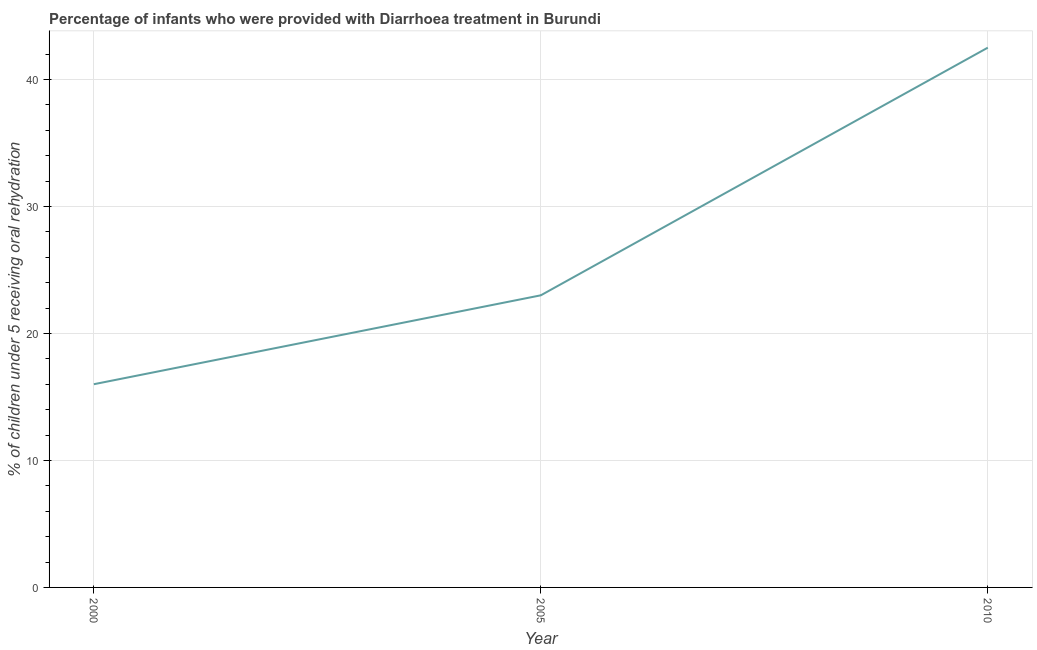What is the percentage of children who were provided with treatment diarrhoea in 2010?
Your answer should be compact. 42.5. Across all years, what is the maximum percentage of children who were provided with treatment diarrhoea?
Keep it short and to the point. 42.5. Across all years, what is the minimum percentage of children who were provided with treatment diarrhoea?
Offer a terse response. 16. In which year was the percentage of children who were provided with treatment diarrhoea maximum?
Provide a short and direct response. 2010. What is the sum of the percentage of children who were provided with treatment diarrhoea?
Your answer should be very brief. 81.5. What is the difference between the percentage of children who were provided with treatment diarrhoea in 2000 and 2005?
Provide a succinct answer. -7. What is the average percentage of children who were provided with treatment diarrhoea per year?
Your response must be concise. 27.17. In how many years, is the percentage of children who were provided with treatment diarrhoea greater than 16 %?
Keep it short and to the point. 2. What is the ratio of the percentage of children who were provided with treatment diarrhoea in 2000 to that in 2005?
Your answer should be compact. 0.7. Is the percentage of children who were provided with treatment diarrhoea in 2005 less than that in 2010?
Your answer should be compact. Yes. Is the sum of the percentage of children who were provided with treatment diarrhoea in 2000 and 2005 greater than the maximum percentage of children who were provided with treatment diarrhoea across all years?
Provide a short and direct response. No. In how many years, is the percentage of children who were provided with treatment diarrhoea greater than the average percentage of children who were provided with treatment diarrhoea taken over all years?
Provide a succinct answer. 1. How many years are there in the graph?
Provide a succinct answer. 3. What is the difference between two consecutive major ticks on the Y-axis?
Your response must be concise. 10. What is the title of the graph?
Make the answer very short. Percentage of infants who were provided with Diarrhoea treatment in Burundi. What is the label or title of the X-axis?
Your response must be concise. Year. What is the label or title of the Y-axis?
Provide a succinct answer. % of children under 5 receiving oral rehydration. What is the % of children under 5 receiving oral rehydration of 2005?
Provide a short and direct response. 23. What is the % of children under 5 receiving oral rehydration of 2010?
Provide a succinct answer. 42.5. What is the difference between the % of children under 5 receiving oral rehydration in 2000 and 2010?
Offer a terse response. -26.5. What is the difference between the % of children under 5 receiving oral rehydration in 2005 and 2010?
Give a very brief answer. -19.5. What is the ratio of the % of children under 5 receiving oral rehydration in 2000 to that in 2005?
Provide a succinct answer. 0.7. What is the ratio of the % of children under 5 receiving oral rehydration in 2000 to that in 2010?
Offer a very short reply. 0.38. What is the ratio of the % of children under 5 receiving oral rehydration in 2005 to that in 2010?
Your answer should be very brief. 0.54. 